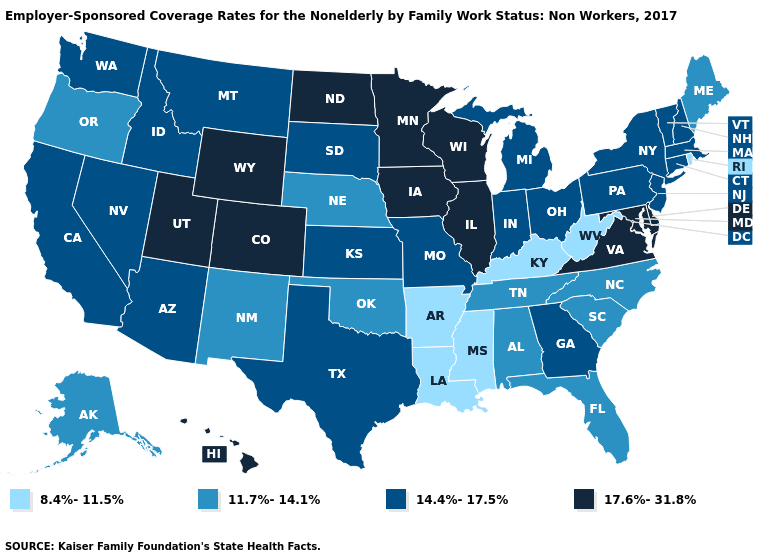What is the value of Nebraska?
Give a very brief answer. 11.7%-14.1%. Does the first symbol in the legend represent the smallest category?
Answer briefly. Yes. Among the states that border Georgia , which have the lowest value?
Quick response, please. Alabama, Florida, North Carolina, South Carolina, Tennessee. Name the states that have a value in the range 8.4%-11.5%?
Quick response, please. Arkansas, Kentucky, Louisiana, Mississippi, Rhode Island, West Virginia. Name the states that have a value in the range 11.7%-14.1%?
Quick response, please. Alabama, Alaska, Florida, Maine, Nebraska, New Mexico, North Carolina, Oklahoma, Oregon, South Carolina, Tennessee. How many symbols are there in the legend?
Quick response, please. 4. Which states hav the highest value in the MidWest?
Answer briefly. Illinois, Iowa, Minnesota, North Dakota, Wisconsin. Does Rhode Island have the lowest value in the Northeast?
Answer briefly. Yes. What is the value of Nebraska?
Short answer required. 11.7%-14.1%. Which states have the lowest value in the MidWest?
Write a very short answer. Nebraska. Name the states that have a value in the range 8.4%-11.5%?
Give a very brief answer. Arkansas, Kentucky, Louisiana, Mississippi, Rhode Island, West Virginia. Name the states that have a value in the range 8.4%-11.5%?
Give a very brief answer. Arkansas, Kentucky, Louisiana, Mississippi, Rhode Island, West Virginia. Which states have the highest value in the USA?
Keep it brief. Colorado, Delaware, Hawaii, Illinois, Iowa, Maryland, Minnesota, North Dakota, Utah, Virginia, Wisconsin, Wyoming. Does the first symbol in the legend represent the smallest category?
Keep it brief. Yes. 